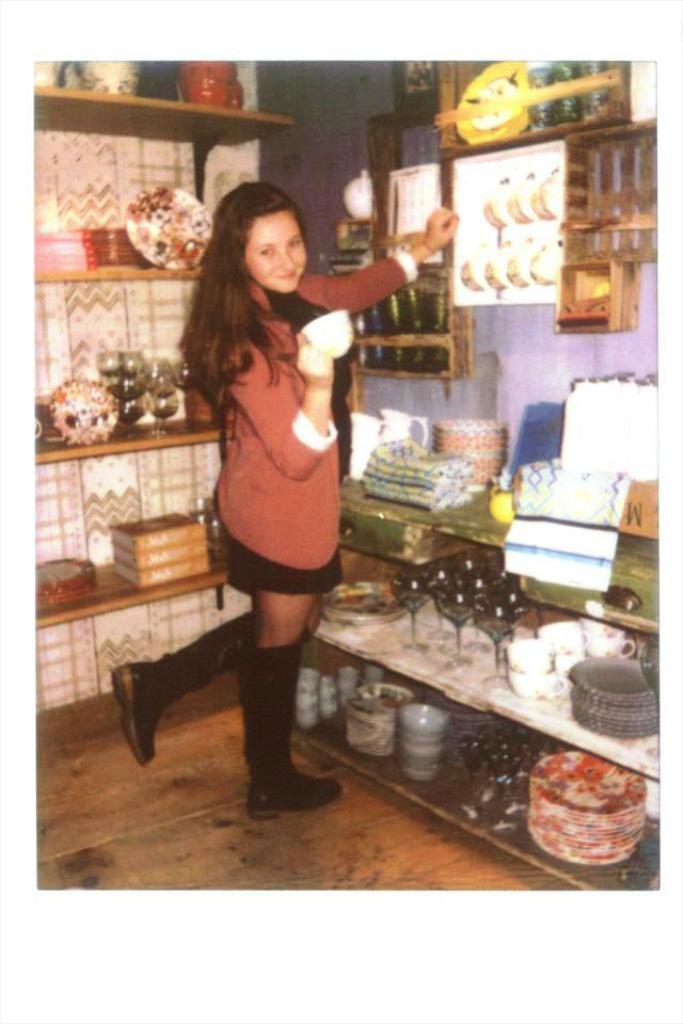In one or two sentences, can you explain what this image depicts? Here we can see a girl is standing on one leg on the floor by holding a glass in her hand. In the background there are plates,glasses,bowls,cups,jars,books on the racks and there are clothes and other objects on a table. There is a standing with some objects on it on the wall. 